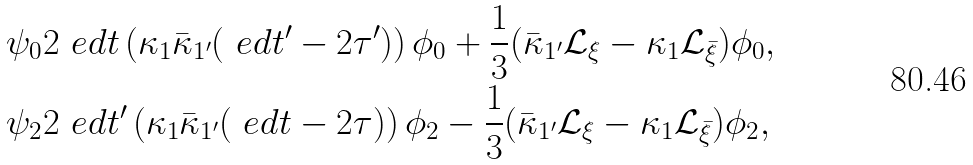Convert formula to latex. <formula><loc_0><loc_0><loc_500><loc_500>\psi _ { 0 } & 2 \ e d t \left ( \kappa _ { 1 } \bar { \kappa } _ { 1 ^ { \prime } } ( \ e d t ^ { \prime } - 2 \tau ^ { \prime } ) \right ) \phi _ { 0 } + \frac { 1 } { 3 } ( \bar { \kappa } _ { 1 ^ { \prime } } \mathcal { L } _ { \xi } - \kappa _ { 1 } \mathcal { L } _ { \bar { \xi } } ) \phi _ { 0 } , \\ \psi _ { 2 } & 2 \ e d t ^ { \prime } \left ( \kappa _ { 1 } \bar { \kappa } _ { 1 ^ { \prime } } ( \ e d t - 2 \tau ) \right ) \phi _ { 2 } - \frac { 1 } { 3 } ( \bar { \kappa } _ { 1 ^ { \prime } } \mathcal { L } _ { \xi } - \kappa _ { 1 } \mathcal { L } _ { \bar { \xi } } ) \phi _ { 2 } ,</formula> 